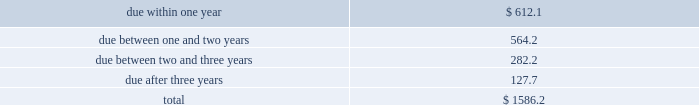Table of contents totaled an absolute notional equivalent of $ 292.3 million and $ 190.5 million , respectively , with the year-over-year increase primarily driven by earnings growth .
At this time , we do not hedge these long-term investment exposures .
We do not use foreign exchange contracts for speculative trading purposes , nor do we hedge our foreign currency exposure in a manner that entirely offsets the effects of changes in foreign exchange rates .
We regularly review our hedging program and assess the need to utilize financial instruments to hedge currency exposures on an ongoing basis .
Cash flow hedging 2014hedges of forecasted foreign currency revenue we may use foreign exchange purchased options or forward contracts to hedge foreign currency revenue denominated in euros , british pounds and japanese yen .
We hedge these cash flow exposures to reduce the risk that our earnings and cash flows will be adversely affected by changes in exchange rates .
These foreign exchange contracts , carried at fair value , may have maturities between one and twelve months .
We enter into these foreign exchange contracts to hedge forecasted revenue in the normal course of business and accordingly , they are not speculative in nature .
We record changes in the intrinsic value of these cash flow hedges in accumulated other comprehensive income ( loss ) until the forecasted transaction occurs .
When the forecasted transaction occurs , we reclassify the related gain or loss on the cash flow hedge to revenue .
In the event the underlying forecasted transaction does not occur , or it becomes probable that it will not occur , we reclassify the gain or loss on the related cash flow hedge from accumulated other comprehensive income ( loss ) to interest and other income , net on our consolidated statements of income at that time .
For the fiscal year ended november 30 , 2018 , there were no net gains or losses recognized in other income relating to hedges of forecasted transactions that did not occur .
Balance sheet hedging 2014hedging of foreign currency assets and liabilities we hedge exposures related to our net recognized foreign currency assets and liabilities with foreign exchange forward contracts to reduce the risk that our earnings and cash flows will be adversely affected by changes in foreign currency exchange rates .
These foreign exchange contracts are carried at fair value with changes in the fair value recorded as interest and other income , net .
These foreign exchange contracts do not subject us to material balance sheet risk due to exchange rate movements because gains and losses on these contracts are intended to offset gains and losses on the assets and liabilities being hedged .
At november 30 , 2018 , the outstanding balance sheet hedging derivatives had maturities of 180 days or less .
See note 5 of our notes to consolidated financial statements for information regarding our hedging activities .
Interest rate risk short-term investments and fixed income securities at november 30 , 2018 , we had debt securities classified as short-term investments of $ 1.59 billion .
Changes in interest rates could adversely affect the market value of these investments .
The table separates these investments , based on stated maturities , to show the approximate exposure to interest rates ( in millions ) : .
A sensitivity analysis was performed on our investment portfolio as of november 30 , 2018 .
The analysis is based on an estimate of the hypothetical changes in market value of the portfolio that would result from an immediate parallel shift in the yield curve of various magnitudes. .
In millions , what are the st investments due between two and three years and due after three years? 
Computations: (282.2 + 127.7)
Answer: 409.9. Table of contents totaled an absolute notional equivalent of $ 292.3 million and $ 190.5 million , respectively , with the year-over-year increase primarily driven by earnings growth .
At this time , we do not hedge these long-term investment exposures .
We do not use foreign exchange contracts for speculative trading purposes , nor do we hedge our foreign currency exposure in a manner that entirely offsets the effects of changes in foreign exchange rates .
We regularly review our hedging program and assess the need to utilize financial instruments to hedge currency exposures on an ongoing basis .
Cash flow hedging 2014hedges of forecasted foreign currency revenue we may use foreign exchange purchased options or forward contracts to hedge foreign currency revenue denominated in euros , british pounds and japanese yen .
We hedge these cash flow exposures to reduce the risk that our earnings and cash flows will be adversely affected by changes in exchange rates .
These foreign exchange contracts , carried at fair value , may have maturities between one and twelve months .
We enter into these foreign exchange contracts to hedge forecasted revenue in the normal course of business and accordingly , they are not speculative in nature .
We record changes in the intrinsic value of these cash flow hedges in accumulated other comprehensive income ( loss ) until the forecasted transaction occurs .
When the forecasted transaction occurs , we reclassify the related gain or loss on the cash flow hedge to revenue .
In the event the underlying forecasted transaction does not occur , or it becomes probable that it will not occur , we reclassify the gain or loss on the related cash flow hedge from accumulated other comprehensive income ( loss ) to interest and other income , net on our consolidated statements of income at that time .
For the fiscal year ended november 30 , 2018 , there were no net gains or losses recognized in other income relating to hedges of forecasted transactions that did not occur .
Balance sheet hedging 2014hedging of foreign currency assets and liabilities we hedge exposures related to our net recognized foreign currency assets and liabilities with foreign exchange forward contracts to reduce the risk that our earnings and cash flows will be adversely affected by changes in foreign currency exchange rates .
These foreign exchange contracts are carried at fair value with changes in the fair value recorded as interest and other income , net .
These foreign exchange contracts do not subject us to material balance sheet risk due to exchange rate movements because gains and losses on these contracts are intended to offset gains and losses on the assets and liabilities being hedged .
At november 30 , 2018 , the outstanding balance sheet hedging derivatives had maturities of 180 days or less .
See note 5 of our notes to consolidated financial statements for information regarding our hedging activities .
Interest rate risk short-term investments and fixed income securities at november 30 , 2018 , we had debt securities classified as short-term investments of $ 1.59 billion .
Changes in interest rates could adversely affect the market value of these investments .
The table separates these investments , based on stated maturities , to show the approximate exposure to interest rates ( in millions ) : .
A sensitivity analysis was performed on our investment portfolio as of november 30 , 2018 .
The analysis is based on an estimate of the hypothetical changes in market value of the portfolio that would result from an immediate parallel shift in the yield curve of various magnitudes. .
What portion of the presented investments is due within 12 months? 
Computations: (612.1 / 1586.2)
Answer: 0.38589. 